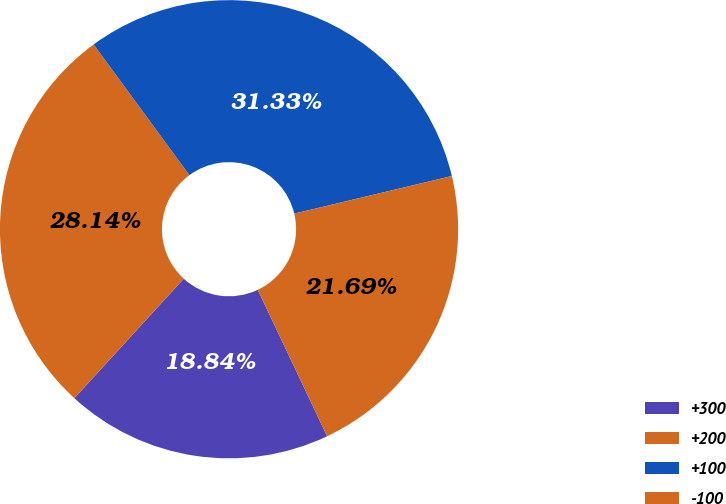<chart> <loc_0><loc_0><loc_500><loc_500><pie_chart><fcel>+300<fcel>+200<fcel>+100<fcel>-100<nl><fcel>18.84%<fcel>28.14%<fcel>31.33%<fcel>21.69%<nl></chart> 